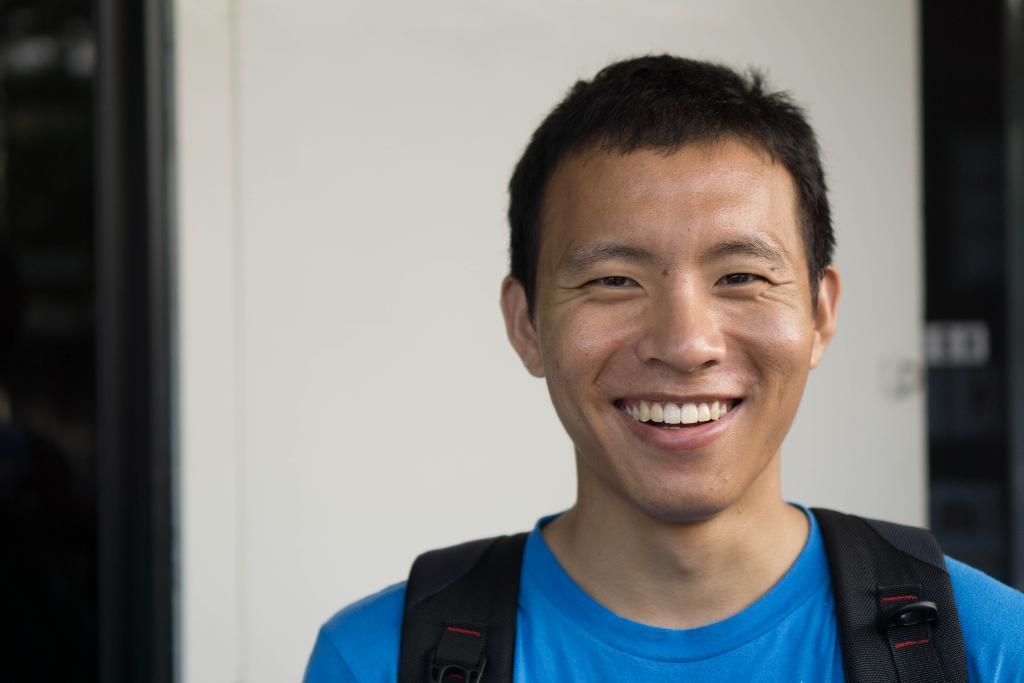Can you describe this image briefly? This image consists of a man wearing a blue T-shirt and a backpack. He is laughing. In the background, we can see a door in white color. 